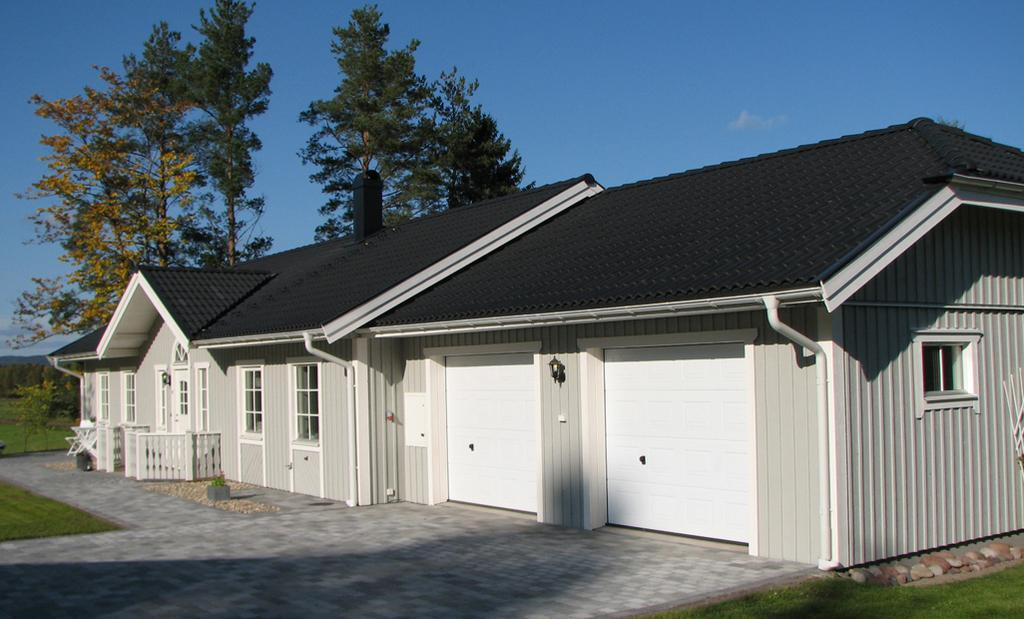What type of structures can be seen in the image? There are sheds in the image. What can be seen in the background of the image? There are trees in the background of the image. What type of kitten is depicted in the image? There is no kitten present in the image; it features sheds and trees. What disease is being treated in the image? There is no indication of any disease or treatment in the image. 